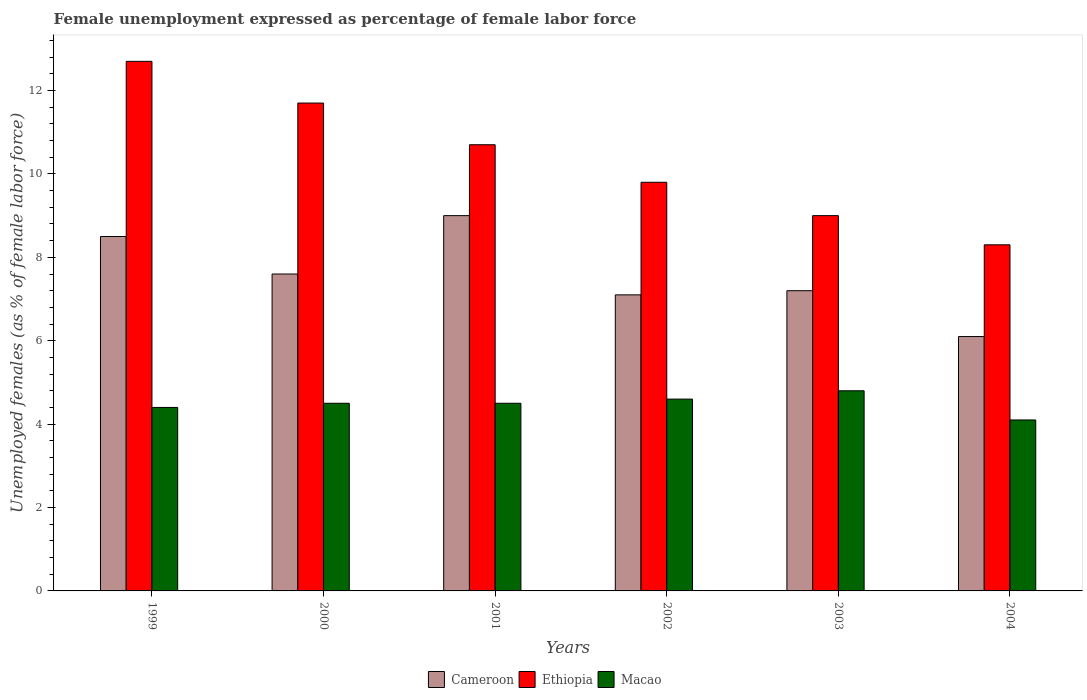How many different coloured bars are there?
Provide a short and direct response. 3. How many groups of bars are there?
Offer a terse response. 6. How many bars are there on the 2nd tick from the left?
Offer a very short reply. 3. How many bars are there on the 5th tick from the right?
Your response must be concise. 3. What is the label of the 6th group of bars from the left?
Provide a succinct answer. 2004. What is the unemployment in females in in Cameroon in 2000?
Ensure brevity in your answer.  7.6. Across all years, what is the maximum unemployment in females in in Macao?
Your response must be concise. 4.8. Across all years, what is the minimum unemployment in females in in Cameroon?
Make the answer very short. 6.1. In which year was the unemployment in females in in Macao minimum?
Provide a short and direct response. 2004. What is the total unemployment in females in in Ethiopia in the graph?
Offer a very short reply. 62.2. What is the difference between the unemployment in females in in Cameroon in 2001 and that in 2003?
Offer a terse response. 1.8. What is the difference between the unemployment in females in in Macao in 2001 and the unemployment in females in in Ethiopia in 1999?
Your response must be concise. -8.2. What is the average unemployment in females in in Cameroon per year?
Ensure brevity in your answer.  7.58. In the year 1999, what is the difference between the unemployment in females in in Ethiopia and unemployment in females in in Macao?
Offer a very short reply. 8.3. What is the ratio of the unemployment in females in in Macao in 1999 to that in 2002?
Offer a very short reply. 0.96. Is the unemployment in females in in Ethiopia in 2001 less than that in 2004?
Your response must be concise. No. What is the difference between the highest and the second highest unemployment in females in in Macao?
Make the answer very short. 0.2. What is the difference between the highest and the lowest unemployment in females in in Ethiopia?
Your answer should be very brief. 4.4. In how many years, is the unemployment in females in in Ethiopia greater than the average unemployment in females in in Ethiopia taken over all years?
Give a very brief answer. 3. What does the 1st bar from the left in 1999 represents?
Give a very brief answer. Cameroon. What does the 1st bar from the right in 2000 represents?
Offer a terse response. Macao. How many bars are there?
Provide a short and direct response. 18. Are all the bars in the graph horizontal?
Your response must be concise. No. Are the values on the major ticks of Y-axis written in scientific E-notation?
Keep it short and to the point. No. Does the graph contain any zero values?
Provide a short and direct response. No. Where does the legend appear in the graph?
Provide a short and direct response. Bottom center. How are the legend labels stacked?
Your answer should be very brief. Horizontal. What is the title of the graph?
Provide a short and direct response. Female unemployment expressed as percentage of female labor force. What is the label or title of the Y-axis?
Give a very brief answer. Unemployed females (as % of female labor force). What is the Unemployed females (as % of female labor force) in Ethiopia in 1999?
Make the answer very short. 12.7. What is the Unemployed females (as % of female labor force) in Macao in 1999?
Your response must be concise. 4.4. What is the Unemployed females (as % of female labor force) of Cameroon in 2000?
Give a very brief answer. 7.6. What is the Unemployed females (as % of female labor force) of Ethiopia in 2000?
Keep it short and to the point. 11.7. What is the Unemployed females (as % of female labor force) of Macao in 2000?
Your answer should be compact. 4.5. What is the Unemployed females (as % of female labor force) of Cameroon in 2001?
Your answer should be compact. 9. What is the Unemployed females (as % of female labor force) in Ethiopia in 2001?
Offer a very short reply. 10.7. What is the Unemployed females (as % of female labor force) of Macao in 2001?
Ensure brevity in your answer.  4.5. What is the Unemployed females (as % of female labor force) of Cameroon in 2002?
Provide a short and direct response. 7.1. What is the Unemployed females (as % of female labor force) in Ethiopia in 2002?
Give a very brief answer. 9.8. What is the Unemployed females (as % of female labor force) of Macao in 2002?
Offer a very short reply. 4.6. What is the Unemployed females (as % of female labor force) in Cameroon in 2003?
Ensure brevity in your answer.  7.2. What is the Unemployed females (as % of female labor force) in Ethiopia in 2003?
Offer a very short reply. 9. What is the Unemployed females (as % of female labor force) in Macao in 2003?
Keep it short and to the point. 4.8. What is the Unemployed females (as % of female labor force) of Cameroon in 2004?
Make the answer very short. 6.1. What is the Unemployed females (as % of female labor force) of Ethiopia in 2004?
Your answer should be compact. 8.3. What is the Unemployed females (as % of female labor force) of Macao in 2004?
Your answer should be compact. 4.1. Across all years, what is the maximum Unemployed females (as % of female labor force) of Ethiopia?
Offer a very short reply. 12.7. Across all years, what is the maximum Unemployed females (as % of female labor force) of Macao?
Offer a terse response. 4.8. Across all years, what is the minimum Unemployed females (as % of female labor force) of Cameroon?
Your response must be concise. 6.1. Across all years, what is the minimum Unemployed females (as % of female labor force) of Ethiopia?
Give a very brief answer. 8.3. Across all years, what is the minimum Unemployed females (as % of female labor force) in Macao?
Make the answer very short. 4.1. What is the total Unemployed females (as % of female labor force) of Cameroon in the graph?
Your answer should be very brief. 45.5. What is the total Unemployed females (as % of female labor force) in Ethiopia in the graph?
Your answer should be compact. 62.2. What is the total Unemployed females (as % of female labor force) in Macao in the graph?
Offer a very short reply. 26.9. What is the difference between the Unemployed females (as % of female labor force) of Ethiopia in 1999 and that in 2000?
Ensure brevity in your answer.  1. What is the difference between the Unemployed females (as % of female labor force) of Macao in 1999 and that in 2001?
Make the answer very short. -0.1. What is the difference between the Unemployed females (as % of female labor force) in Cameroon in 1999 and that in 2002?
Ensure brevity in your answer.  1.4. What is the difference between the Unemployed females (as % of female labor force) of Ethiopia in 1999 and that in 2002?
Ensure brevity in your answer.  2.9. What is the difference between the Unemployed females (as % of female labor force) in Macao in 1999 and that in 2003?
Offer a terse response. -0.4. What is the difference between the Unemployed females (as % of female labor force) of Cameroon in 1999 and that in 2004?
Provide a succinct answer. 2.4. What is the difference between the Unemployed females (as % of female labor force) in Macao in 1999 and that in 2004?
Ensure brevity in your answer.  0.3. What is the difference between the Unemployed females (as % of female labor force) in Macao in 2000 and that in 2001?
Your response must be concise. 0. What is the difference between the Unemployed females (as % of female labor force) of Cameroon in 2000 and that in 2002?
Your answer should be very brief. 0.5. What is the difference between the Unemployed females (as % of female labor force) in Ethiopia in 2000 and that in 2003?
Your answer should be very brief. 2.7. What is the difference between the Unemployed females (as % of female labor force) of Macao in 2000 and that in 2003?
Your answer should be compact. -0.3. What is the difference between the Unemployed females (as % of female labor force) in Ethiopia in 2000 and that in 2004?
Offer a terse response. 3.4. What is the difference between the Unemployed females (as % of female labor force) in Ethiopia in 2001 and that in 2002?
Ensure brevity in your answer.  0.9. What is the difference between the Unemployed females (as % of female labor force) of Macao in 2001 and that in 2002?
Offer a terse response. -0.1. What is the difference between the Unemployed females (as % of female labor force) of Ethiopia in 2001 and that in 2003?
Provide a succinct answer. 1.7. What is the difference between the Unemployed females (as % of female labor force) of Cameroon in 2001 and that in 2004?
Offer a very short reply. 2.9. What is the difference between the Unemployed females (as % of female labor force) in Macao in 2001 and that in 2004?
Offer a terse response. 0.4. What is the difference between the Unemployed females (as % of female labor force) of Ethiopia in 2002 and that in 2003?
Your response must be concise. 0.8. What is the difference between the Unemployed females (as % of female labor force) in Macao in 2002 and that in 2003?
Give a very brief answer. -0.2. What is the difference between the Unemployed females (as % of female labor force) in Cameroon in 2002 and that in 2004?
Provide a short and direct response. 1. What is the difference between the Unemployed females (as % of female labor force) in Cameroon in 2003 and that in 2004?
Your answer should be compact. 1.1. What is the difference between the Unemployed females (as % of female labor force) of Macao in 2003 and that in 2004?
Your answer should be very brief. 0.7. What is the difference between the Unemployed females (as % of female labor force) of Ethiopia in 1999 and the Unemployed females (as % of female labor force) of Macao in 2000?
Provide a succinct answer. 8.2. What is the difference between the Unemployed females (as % of female labor force) in Cameroon in 1999 and the Unemployed females (as % of female labor force) in Ethiopia in 2001?
Offer a very short reply. -2.2. What is the difference between the Unemployed females (as % of female labor force) of Cameroon in 1999 and the Unemployed females (as % of female labor force) of Macao in 2001?
Your answer should be very brief. 4. What is the difference between the Unemployed females (as % of female labor force) of Ethiopia in 1999 and the Unemployed females (as % of female labor force) of Macao in 2001?
Make the answer very short. 8.2. What is the difference between the Unemployed females (as % of female labor force) in Cameroon in 1999 and the Unemployed females (as % of female labor force) in Macao in 2002?
Your answer should be compact. 3.9. What is the difference between the Unemployed females (as % of female labor force) in Cameroon in 1999 and the Unemployed females (as % of female labor force) in Ethiopia in 2003?
Your response must be concise. -0.5. What is the difference between the Unemployed females (as % of female labor force) of Cameroon in 1999 and the Unemployed females (as % of female labor force) of Macao in 2003?
Your answer should be very brief. 3.7. What is the difference between the Unemployed females (as % of female labor force) of Cameroon in 1999 and the Unemployed females (as % of female labor force) of Macao in 2004?
Give a very brief answer. 4.4. What is the difference between the Unemployed females (as % of female labor force) in Cameroon in 2000 and the Unemployed females (as % of female labor force) in Ethiopia in 2001?
Offer a very short reply. -3.1. What is the difference between the Unemployed females (as % of female labor force) in Ethiopia in 2000 and the Unemployed females (as % of female labor force) in Macao in 2001?
Your answer should be very brief. 7.2. What is the difference between the Unemployed females (as % of female labor force) in Cameroon in 2000 and the Unemployed females (as % of female labor force) in Ethiopia in 2002?
Make the answer very short. -2.2. What is the difference between the Unemployed females (as % of female labor force) in Ethiopia in 2000 and the Unemployed females (as % of female labor force) in Macao in 2002?
Your response must be concise. 7.1. What is the difference between the Unemployed females (as % of female labor force) of Cameroon in 2000 and the Unemployed females (as % of female labor force) of Macao in 2004?
Your answer should be compact. 3.5. What is the difference between the Unemployed females (as % of female labor force) of Ethiopia in 2000 and the Unemployed females (as % of female labor force) of Macao in 2004?
Give a very brief answer. 7.6. What is the difference between the Unemployed females (as % of female labor force) of Cameroon in 2001 and the Unemployed females (as % of female labor force) of Macao in 2002?
Make the answer very short. 4.4. What is the difference between the Unemployed females (as % of female labor force) of Ethiopia in 2001 and the Unemployed females (as % of female labor force) of Macao in 2003?
Ensure brevity in your answer.  5.9. What is the difference between the Unemployed females (as % of female labor force) of Ethiopia in 2001 and the Unemployed females (as % of female labor force) of Macao in 2004?
Provide a succinct answer. 6.6. What is the difference between the Unemployed females (as % of female labor force) in Cameroon in 2002 and the Unemployed females (as % of female labor force) in Ethiopia in 2003?
Offer a terse response. -1.9. What is the difference between the Unemployed females (as % of female labor force) in Ethiopia in 2002 and the Unemployed females (as % of female labor force) in Macao in 2003?
Your answer should be very brief. 5. What is the difference between the Unemployed females (as % of female labor force) in Cameroon in 2002 and the Unemployed females (as % of female labor force) in Macao in 2004?
Provide a short and direct response. 3. What is the difference between the Unemployed females (as % of female labor force) of Ethiopia in 2002 and the Unemployed females (as % of female labor force) of Macao in 2004?
Your answer should be very brief. 5.7. What is the difference between the Unemployed females (as % of female labor force) of Cameroon in 2003 and the Unemployed females (as % of female labor force) of Ethiopia in 2004?
Provide a short and direct response. -1.1. What is the difference between the Unemployed females (as % of female labor force) in Ethiopia in 2003 and the Unemployed females (as % of female labor force) in Macao in 2004?
Your answer should be very brief. 4.9. What is the average Unemployed females (as % of female labor force) of Cameroon per year?
Your answer should be compact. 7.58. What is the average Unemployed females (as % of female labor force) of Ethiopia per year?
Offer a terse response. 10.37. What is the average Unemployed females (as % of female labor force) in Macao per year?
Offer a very short reply. 4.48. In the year 1999, what is the difference between the Unemployed females (as % of female labor force) of Cameroon and Unemployed females (as % of female labor force) of Ethiopia?
Provide a succinct answer. -4.2. In the year 1999, what is the difference between the Unemployed females (as % of female labor force) in Cameroon and Unemployed females (as % of female labor force) in Macao?
Keep it short and to the point. 4.1. In the year 1999, what is the difference between the Unemployed females (as % of female labor force) in Ethiopia and Unemployed females (as % of female labor force) in Macao?
Keep it short and to the point. 8.3. In the year 2000, what is the difference between the Unemployed females (as % of female labor force) of Cameroon and Unemployed females (as % of female labor force) of Ethiopia?
Your answer should be compact. -4.1. In the year 2000, what is the difference between the Unemployed females (as % of female labor force) in Cameroon and Unemployed females (as % of female labor force) in Macao?
Ensure brevity in your answer.  3.1. In the year 2000, what is the difference between the Unemployed females (as % of female labor force) in Ethiopia and Unemployed females (as % of female labor force) in Macao?
Ensure brevity in your answer.  7.2. In the year 2001, what is the difference between the Unemployed females (as % of female labor force) in Cameroon and Unemployed females (as % of female labor force) in Macao?
Provide a succinct answer. 4.5. In the year 2003, what is the difference between the Unemployed females (as % of female labor force) of Cameroon and Unemployed females (as % of female labor force) of Ethiopia?
Give a very brief answer. -1.8. In the year 2003, what is the difference between the Unemployed females (as % of female labor force) in Ethiopia and Unemployed females (as % of female labor force) in Macao?
Offer a very short reply. 4.2. In the year 2004, what is the difference between the Unemployed females (as % of female labor force) in Cameroon and Unemployed females (as % of female labor force) in Macao?
Your response must be concise. 2. In the year 2004, what is the difference between the Unemployed females (as % of female labor force) of Ethiopia and Unemployed females (as % of female labor force) of Macao?
Provide a short and direct response. 4.2. What is the ratio of the Unemployed females (as % of female labor force) of Cameroon in 1999 to that in 2000?
Ensure brevity in your answer.  1.12. What is the ratio of the Unemployed females (as % of female labor force) of Ethiopia in 1999 to that in 2000?
Provide a short and direct response. 1.09. What is the ratio of the Unemployed females (as % of female labor force) in Macao in 1999 to that in 2000?
Make the answer very short. 0.98. What is the ratio of the Unemployed females (as % of female labor force) in Ethiopia in 1999 to that in 2001?
Provide a short and direct response. 1.19. What is the ratio of the Unemployed females (as % of female labor force) in Macao in 1999 to that in 2001?
Your answer should be compact. 0.98. What is the ratio of the Unemployed females (as % of female labor force) in Cameroon in 1999 to that in 2002?
Provide a succinct answer. 1.2. What is the ratio of the Unemployed females (as % of female labor force) in Ethiopia in 1999 to that in 2002?
Keep it short and to the point. 1.3. What is the ratio of the Unemployed females (as % of female labor force) of Macao in 1999 to that in 2002?
Your answer should be compact. 0.96. What is the ratio of the Unemployed females (as % of female labor force) in Cameroon in 1999 to that in 2003?
Offer a very short reply. 1.18. What is the ratio of the Unemployed females (as % of female labor force) of Ethiopia in 1999 to that in 2003?
Your answer should be compact. 1.41. What is the ratio of the Unemployed females (as % of female labor force) of Macao in 1999 to that in 2003?
Ensure brevity in your answer.  0.92. What is the ratio of the Unemployed females (as % of female labor force) in Cameroon in 1999 to that in 2004?
Your answer should be compact. 1.39. What is the ratio of the Unemployed females (as % of female labor force) in Ethiopia in 1999 to that in 2004?
Give a very brief answer. 1.53. What is the ratio of the Unemployed females (as % of female labor force) of Macao in 1999 to that in 2004?
Keep it short and to the point. 1.07. What is the ratio of the Unemployed females (as % of female labor force) of Cameroon in 2000 to that in 2001?
Provide a succinct answer. 0.84. What is the ratio of the Unemployed females (as % of female labor force) in Ethiopia in 2000 to that in 2001?
Give a very brief answer. 1.09. What is the ratio of the Unemployed females (as % of female labor force) in Macao in 2000 to that in 2001?
Ensure brevity in your answer.  1. What is the ratio of the Unemployed females (as % of female labor force) of Cameroon in 2000 to that in 2002?
Ensure brevity in your answer.  1.07. What is the ratio of the Unemployed females (as % of female labor force) of Ethiopia in 2000 to that in 2002?
Your answer should be very brief. 1.19. What is the ratio of the Unemployed females (as % of female labor force) in Macao in 2000 to that in 2002?
Your answer should be very brief. 0.98. What is the ratio of the Unemployed females (as % of female labor force) of Cameroon in 2000 to that in 2003?
Keep it short and to the point. 1.06. What is the ratio of the Unemployed females (as % of female labor force) in Cameroon in 2000 to that in 2004?
Your answer should be compact. 1.25. What is the ratio of the Unemployed females (as % of female labor force) in Ethiopia in 2000 to that in 2004?
Keep it short and to the point. 1.41. What is the ratio of the Unemployed females (as % of female labor force) in Macao in 2000 to that in 2004?
Your response must be concise. 1.1. What is the ratio of the Unemployed females (as % of female labor force) of Cameroon in 2001 to that in 2002?
Your response must be concise. 1.27. What is the ratio of the Unemployed females (as % of female labor force) in Ethiopia in 2001 to that in 2002?
Your answer should be very brief. 1.09. What is the ratio of the Unemployed females (as % of female labor force) of Macao in 2001 to that in 2002?
Provide a short and direct response. 0.98. What is the ratio of the Unemployed females (as % of female labor force) of Cameroon in 2001 to that in 2003?
Keep it short and to the point. 1.25. What is the ratio of the Unemployed females (as % of female labor force) in Ethiopia in 2001 to that in 2003?
Your response must be concise. 1.19. What is the ratio of the Unemployed females (as % of female labor force) of Cameroon in 2001 to that in 2004?
Your answer should be compact. 1.48. What is the ratio of the Unemployed females (as % of female labor force) in Ethiopia in 2001 to that in 2004?
Offer a terse response. 1.29. What is the ratio of the Unemployed females (as % of female labor force) in Macao in 2001 to that in 2004?
Provide a short and direct response. 1.1. What is the ratio of the Unemployed females (as % of female labor force) in Cameroon in 2002 to that in 2003?
Provide a succinct answer. 0.99. What is the ratio of the Unemployed females (as % of female labor force) in Ethiopia in 2002 to that in 2003?
Give a very brief answer. 1.09. What is the ratio of the Unemployed females (as % of female labor force) of Cameroon in 2002 to that in 2004?
Offer a terse response. 1.16. What is the ratio of the Unemployed females (as % of female labor force) of Ethiopia in 2002 to that in 2004?
Give a very brief answer. 1.18. What is the ratio of the Unemployed females (as % of female labor force) in Macao in 2002 to that in 2004?
Ensure brevity in your answer.  1.12. What is the ratio of the Unemployed females (as % of female labor force) in Cameroon in 2003 to that in 2004?
Offer a terse response. 1.18. What is the ratio of the Unemployed females (as % of female labor force) in Ethiopia in 2003 to that in 2004?
Provide a succinct answer. 1.08. What is the ratio of the Unemployed females (as % of female labor force) of Macao in 2003 to that in 2004?
Ensure brevity in your answer.  1.17. What is the difference between the highest and the second highest Unemployed females (as % of female labor force) of Ethiopia?
Ensure brevity in your answer.  1. What is the difference between the highest and the second highest Unemployed females (as % of female labor force) of Macao?
Offer a terse response. 0.2. What is the difference between the highest and the lowest Unemployed females (as % of female labor force) of Cameroon?
Your answer should be very brief. 2.9. What is the difference between the highest and the lowest Unemployed females (as % of female labor force) in Ethiopia?
Offer a very short reply. 4.4. 